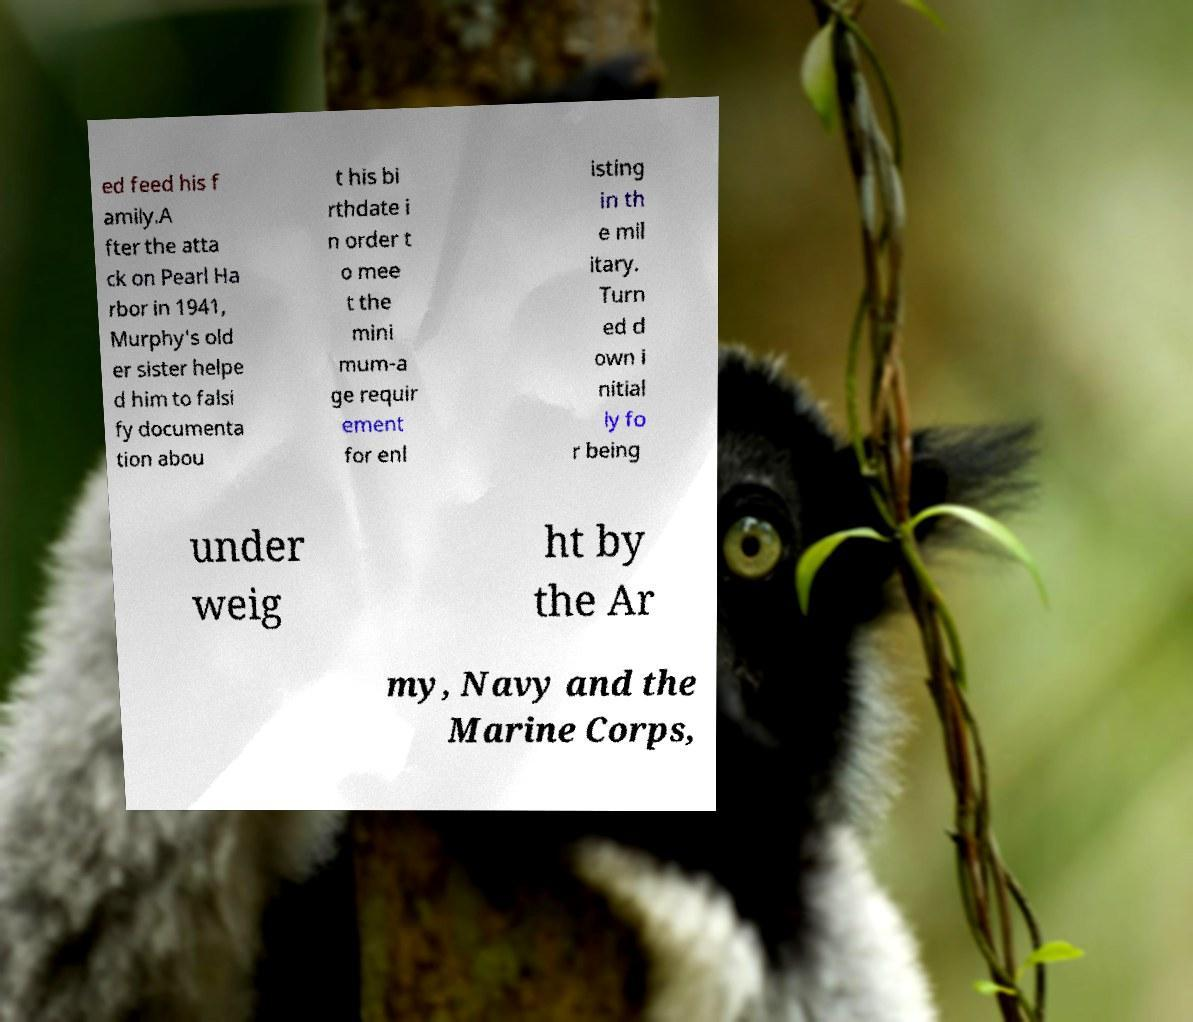I need the written content from this picture converted into text. Can you do that? ed feed his f amily.A fter the atta ck on Pearl Ha rbor in 1941, Murphy's old er sister helpe d him to falsi fy documenta tion abou t his bi rthdate i n order t o mee t the mini mum-a ge requir ement for enl isting in th e mil itary. Turn ed d own i nitial ly fo r being under weig ht by the Ar my, Navy and the Marine Corps, 